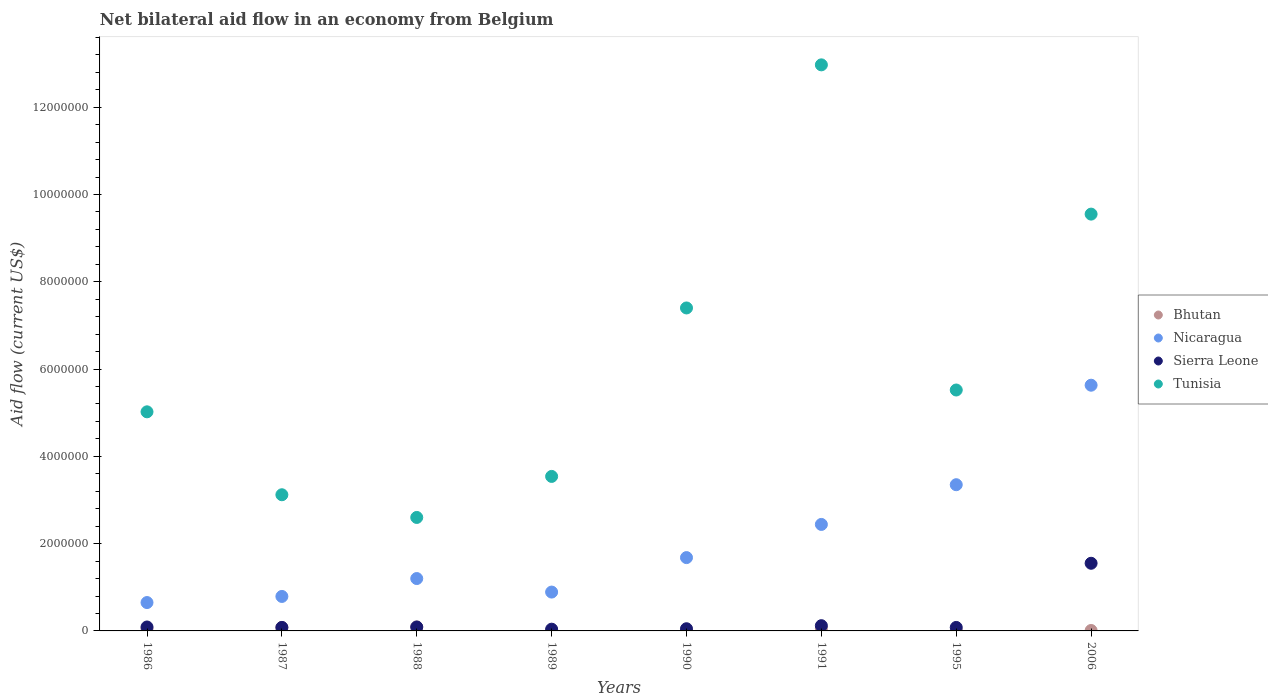How many different coloured dotlines are there?
Offer a terse response. 4. Across all years, what is the maximum net bilateral aid flow in Nicaragua?
Provide a succinct answer. 5.63e+06. Across all years, what is the minimum net bilateral aid flow in Tunisia?
Offer a very short reply. 2.60e+06. In which year was the net bilateral aid flow in Bhutan minimum?
Keep it short and to the point. 1989. What is the total net bilateral aid flow in Bhutan in the graph?
Offer a very short reply. 3.10e+05. What is the difference between the net bilateral aid flow in Bhutan in 1986 and that in 1987?
Provide a succinct answer. -3.00e+04. What is the difference between the net bilateral aid flow in Nicaragua in 1988 and the net bilateral aid flow in Sierra Leone in 1987?
Offer a very short reply. 1.12e+06. What is the average net bilateral aid flow in Bhutan per year?
Provide a short and direct response. 3.88e+04. In the year 1987, what is the difference between the net bilateral aid flow in Sierra Leone and net bilateral aid flow in Tunisia?
Offer a very short reply. -3.04e+06. In how many years, is the net bilateral aid flow in Tunisia greater than 8400000 US$?
Offer a very short reply. 2. What is the difference between the highest and the second highest net bilateral aid flow in Tunisia?
Your answer should be compact. 3.42e+06. What is the difference between the highest and the lowest net bilateral aid flow in Nicaragua?
Your answer should be compact. 4.98e+06. Is it the case that in every year, the sum of the net bilateral aid flow in Nicaragua and net bilateral aid flow in Bhutan  is greater than the sum of net bilateral aid flow in Sierra Leone and net bilateral aid flow in Tunisia?
Give a very brief answer. No. Is it the case that in every year, the sum of the net bilateral aid flow in Nicaragua and net bilateral aid flow in Bhutan  is greater than the net bilateral aid flow in Tunisia?
Make the answer very short. No. Does the net bilateral aid flow in Sierra Leone monotonically increase over the years?
Your answer should be compact. No. Is the net bilateral aid flow in Bhutan strictly less than the net bilateral aid flow in Nicaragua over the years?
Ensure brevity in your answer.  Yes. What is the difference between two consecutive major ticks on the Y-axis?
Offer a very short reply. 2.00e+06. Does the graph contain any zero values?
Your answer should be very brief. No. Does the graph contain grids?
Ensure brevity in your answer.  No. Where does the legend appear in the graph?
Offer a very short reply. Center right. How are the legend labels stacked?
Keep it short and to the point. Vertical. What is the title of the graph?
Your answer should be compact. Net bilateral aid flow in an economy from Belgium. What is the label or title of the X-axis?
Your answer should be very brief. Years. What is the Aid flow (current US$) of Nicaragua in 1986?
Provide a short and direct response. 6.50e+05. What is the Aid flow (current US$) in Tunisia in 1986?
Provide a succinct answer. 5.02e+06. What is the Aid flow (current US$) of Nicaragua in 1987?
Provide a succinct answer. 7.90e+05. What is the Aid flow (current US$) of Sierra Leone in 1987?
Your answer should be compact. 8.00e+04. What is the Aid flow (current US$) of Tunisia in 1987?
Provide a short and direct response. 3.12e+06. What is the Aid flow (current US$) of Nicaragua in 1988?
Keep it short and to the point. 1.20e+06. What is the Aid flow (current US$) of Sierra Leone in 1988?
Your answer should be very brief. 9.00e+04. What is the Aid flow (current US$) in Tunisia in 1988?
Provide a short and direct response. 2.60e+06. What is the Aid flow (current US$) of Bhutan in 1989?
Offer a terse response. 10000. What is the Aid flow (current US$) of Nicaragua in 1989?
Make the answer very short. 8.90e+05. What is the Aid flow (current US$) in Sierra Leone in 1989?
Provide a succinct answer. 4.00e+04. What is the Aid flow (current US$) in Tunisia in 1989?
Your response must be concise. 3.54e+06. What is the Aid flow (current US$) in Nicaragua in 1990?
Your answer should be compact. 1.68e+06. What is the Aid flow (current US$) in Tunisia in 1990?
Ensure brevity in your answer.  7.40e+06. What is the Aid flow (current US$) in Nicaragua in 1991?
Keep it short and to the point. 2.44e+06. What is the Aid flow (current US$) of Sierra Leone in 1991?
Give a very brief answer. 1.20e+05. What is the Aid flow (current US$) in Tunisia in 1991?
Offer a terse response. 1.30e+07. What is the Aid flow (current US$) in Nicaragua in 1995?
Ensure brevity in your answer.  3.35e+06. What is the Aid flow (current US$) in Tunisia in 1995?
Your response must be concise. 5.52e+06. What is the Aid flow (current US$) of Nicaragua in 2006?
Keep it short and to the point. 5.63e+06. What is the Aid flow (current US$) in Sierra Leone in 2006?
Your response must be concise. 1.55e+06. What is the Aid flow (current US$) in Tunisia in 2006?
Offer a terse response. 9.55e+06. Across all years, what is the maximum Aid flow (current US$) of Bhutan?
Offer a terse response. 9.00e+04. Across all years, what is the maximum Aid flow (current US$) in Nicaragua?
Give a very brief answer. 5.63e+06. Across all years, what is the maximum Aid flow (current US$) in Sierra Leone?
Your response must be concise. 1.55e+06. Across all years, what is the maximum Aid flow (current US$) in Tunisia?
Provide a short and direct response. 1.30e+07. Across all years, what is the minimum Aid flow (current US$) in Bhutan?
Offer a terse response. 10000. Across all years, what is the minimum Aid flow (current US$) of Nicaragua?
Your response must be concise. 6.50e+05. Across all years, what is the minimum Aid flow (current US$) in Tunisia?
Your answer should be very brief. 2.60e+06. What is the total Aid flow (current US$) of Nicaragua in the graph?
Your answer should be compact. 1.66e+07. What is the total Aid flow (current US$) in Sierra Leone in the graph?
Provide a short and direct response. 2.10e+06. What is the total Aid flow (current US$) of Tunisia in the graph?
Give a very brief answer. 4.97e+07. What is the difference between the Aid flow (current US$) of Sierra Leone in 1986 and that in 1987?
Your response must be concise. 10000. What is the difference between the Aid flow (current US$) of Tunisia in 1986 and that in 1987?
Your answer should be very brief. 1.90e+06. What is the difference between the Aid flow (current US$) in Nicaragua in 1986 and that in 1988?
Offer a terse response. -5.50e+05. What is the difference between the Aid flow (current US$) in Sierra Leone in 1986 and that in 1988?
Your answer should be very brief. 0. What is the difference between the Aid flow (current US$) of Tunisia in 1986 and that in 1988?
Your answer should be compact. 2.42e+06. What is the difference between the Aid flow (current US$) in Tunisia in 1986 and that in 1989?
Provide a succinct answer. 1.48e+06. What is the difference between the Aid flow (current US$) in Bhutan in 1986 and that in 1990?
Your answer should be compact. 4.00e+04. What is the difference between the Aid flow (current US$) of Nicaragua in 1986 and that in 1990?
Your answer should be very brief. -1.03e+06. What is the difference between the Aid flow (current US$) in Tunisia in 1986 and that in 1990?
Provide a short and direct response. -2.38e+06. What is the difference between the Aid flow (current US$) of Bhutan in 1986 and that in 1991?
Your response must be concise. 0. What is the difference between the Aid flow (current US$) in Nicaragua in 1986 and that in 1991?
Your answer should be very brief. -1.79e+06. What is the difference between the Aid flow (current US$) of Tunisia in 1986 and that in 1991?
Your answer should be very brief. -7.95e+06. What is the difference between the Aid flow (current US$) in Nicaragua in 1986 and that in 1995?
Offer a terse response. -2.70e+06. What is the difference between the Aid flow (current US$) of Tunisia in 1986 and that in 1995?
Ensure brevity in your answer.  -5.00e+05. What is the difference between the Aid flow (current US$) in Nicaragua in 1986 and that in 2006?
Give a very brief answer. -4.98e+06. What is the difference between the Aid flow (current US$) in Sierra Leone in 1986 and that in 2006?
Your answer should be compact. -1.46e+06. What is the difference between the Aid flow (current US$) of Tunisia in 1986 and that in 2006?
Give a very brief answer. -4.53e+06. What is the difference between the Aid flow (current US$) of Bhutan in 1987 and that in 1988?
Your response must be concise. -10000. What is the difference between the Aid flow (current US$) in Nicaragua in 1987 and that in 1988?
Give a very brief answer. -4.10e+05. What is the difference between the Aid flow (current US$) in Tunisia in 1987 and that in 1988?
Provide a short and direct response. 5.20e+05. What is the difference between the Aid flow (current US$) of Bhutan in 1987 and that in 1989?
Your answer should be compact. 7.00e+04. What is the difference between the Aid flow (current US$) of Nicaragua in 1987 and that in 1989?
Your answer should be compact. -1.00e+05. What is the difference between the Aid flow (current US$) of Tunisia in 1987 and that in 1989?
Give a very brief answer. -4.20e+05. What is the difference between the Aid flow (current US$) of Nicaragua in 1987 and that in 1990?
Make the answer very short. -8.90e+05. What is the difference between the Aid flow (current US$) of Sierra Leone in 1987 and that in 1990?
Your answer should be compact. 3.00e+04. What is the difference between the Aid flow (current US$) of Tunisia in 1987 and that in 1990?
Keep it short and to the point. -4.28e+06. What is the difference between the Aid flow (current US$) in Nicaragua in 1987 and that in 1991?
Your answer should be compact. -1.65e+06. What is the difference between the Aid flow (current US$) in Tunisia in 1987 and that in 1991?
Provide a succinct answer. -9.85e+06. What is the difference between the Aid flow (current US$) of Bhutan in 1987 and that in 1995?
Keep it short and to the point. 7.00e+04. What is the difference between the Aid flow (current US$) in Nicaragua in 1987 and that in 1995?
Give a very brief answer. -2.56e+06. What is the difference between the Aid flow (current US$) of Tunisia in 1987 and that in 1995?
Your answer should be compact. -2.40e+06. What is the difference between the Aid flow (current US$) in Bhutan in 1987 and that in 2006?
Provide a short and direct response. 7.00e+04. What is the difference between the Aid flow (current US$) of Nicaragua in 1987 and that in 2006?
Keep it short and to the point. -4.84e+06. What is the difference between the Aid flow (current US$) of Sierra Leone in 1987 and that in 2006?
Make the answer very short. -1.47e+06. What is the difference between the Aid flow (current US$) in Tunisia in 1987 and that in 2006?
Offer a terse response. -6.43e+06. What is the difference between the Aid flow (current US$) in Nicaragua in 1988 and that in 1989?
Keep it short and to the point. 3.10e+05. What is the difference between the Aid flow (current US$) of Sierra Leone in 1988 and that in 1989?
Ensure brevity in your answer.  5.00e+04. What is the difference between the Aid flow (current US$) of Tunisia in 1988 and that in 1989?
Your answer should be very brief. -9.40e+05. What is the difference between the Aid flow (current US$) of Nicaragua in 1988 and that in 1990?
Your response must be concise. -4.80e+05. What is the difference between the Aid flow (current US$) in Tunisia in 1988 and that in 1990?
Ensure brevity in your answer.  -4.80e+06. What is the difference between the Aid flow (current US$) of Bhutan in 1988 and that in 1991?
Offer a terse response. 4.00e+04. What is the difference between the Aid flow (current US$) in Nicaragua in 1988 and that in 1991?
Provide a succinct answer. -1.24e+06. What is the difference between the Aid flow (current US$) in Tunisia in 1988 and that in 1991?
Offer a very short reply. -1.04e+07. What is the difference between the Aid flow (current US$) of Nicaragua in 1988 and that in 1995?
Offer a very short reply. -2.15e+06. What is the difference between the Aid flow (current US$) of Sierra Leone in 1988 and that in 1995?
Offer a terse response. 10000. What is the difference between the Aid flow (current US$) of Tunisia in 1988 and that in 1995?
Offer a very short reply. -2.92e+06. What is the difference between the Aid flow (current US$) of Nicaragua in 1988 and that in 2006?
Provide a succinct answer. -4.43e+06. What is the difference between the Aid flow (current US$) of Sierra Leone in 1988 and that in 2006?
Provide a short and direct response. -1.46e+06. What is the difference between the Aid flow (current US$) in Tunisia in 1988 and that in 2006?
Keep it short and to the point. -6.95e+06. What is the difference between the Aid flow (current US$) in Bhutan in 1989 and that in 1990?
Give a very brief answer. 0. What is the difference between the Aid flow (current US$) of Nicaragua in 1989 and that in 1990?
Keep it short and to the point. -7.90e+05. What is the difference between the Aid flow (current US$) in Tunisia in 1989 and that in 1990?
Offer a terse response. -3.86e+06. What is the difference between the Aid flow (current US$) of Nicaragua in 1989 and that in 1991?
Give a very brief answer. -1.55e+06. What is the difference between the Aid flow (current US$) of Sierra Leone in 1989 and that in 1991?
Your answer should be very brief. -8.00e+04. What is the difference between the Aid flow (current US$) in Tunisia in 1989 and that in 1991?
Offer a very short reply. -9.43e+06. What is the difference between the Aid flow (current US$) in Nicaragua in 1989 and that in 1995?
Keep it short and to the point. -2.46e+06. What is the difference between the Aid flow (current US$) of Tunisia in 1989 and that in 1995?
Your answer should be very brief. -1.98e+06. What is the difference between the Aid flow (current US$) of Nicaragua in 1989 and that in 2006?
Provide a succinct answer. -4.74e+06. What is the difference between the Aid flow (current US$) in Sierra Leone in 1989 and that in 2006?
Keep it short and to the point. -1.51e+06. What is the difference between the Aid flow (current US$) of Tunisia in 1989 and that in 2006?
Offer a very short reply. -6.01e+06. What is the difference between the Aid flow (current US$) of Bhutan in 1990 and that in 1991?
Your response must be concise. -4.00e+04. What is the difference between the Aid flow (current US$) in Nicaragua in 1990 and that in 1991?
Make the answer very short. -7.60e+05. What is the difference between the Aid flow (current US$) in Tunisia in 1990 and that in 1991?
Give a very brief answer. -5.57e+06. What is the difference between the Aid flow (current US$) of Nicaragua in 1990 and that in 1995?
Offer a terse response. -1.67e+06. What is the difference between the Aid flow (current US$) in Tunisia in 1990 and that in 1995?
Ensure brevity in your answer.  1.88e+06. What is the difference between the Aid flow (current US$) of Bhutan in 1990 and that in 2006?
Keep it short and to the point. 0. What is the difference between the Aid flow (current US$) of Nicaragua in 1990 and that in 2006?
Make the answer very short. -3.95e+06. What is the difference between the Aid flow (current US$) in Sierra Leone in 1990 and that in 2006?
Provide a short and direct response. -1.50e+06. What is the difference between the Aid flow (current US$) of Tunisia in 1990 and that in 2006?
Your answer should be very brief. -2.15e+06. What is the difference between the Aid flow (current US$) of Nicaragua in 1991 and that in 1995?
Ensure brevity in your answer.  -9.10e+05. What is the difference between the Aid flow (current US$) in Tunisia in 1991 and that in 1995?
Ensure brevity in your answer.  7.45e+06. What is the difference between the Aid flow (current US$) in Nicaragua in 1991 and that in 2006?
Ensure brevity in your answer.  -3.19e+06. What is the difference between the Aid flow (current US$) of Sierra Leone in 1991 and that in 2006?
Your answer should be very brief. -1.43e+06. What is the difference between the Aid flow (current US$) in Tunisia in 1991 and that in 2006?
Offer a terse response. 3.42e+06. What is the difference between the Aid flow (current US$) of Bhutan in 1995 and that in 2006?
Offer a very short reply. 0. What is the difference between the Aid flow (current US$) of Nicaragua in 1995 and that in 2006?
Provide a short and direct response. -2.28e+06. What is the difference between the Aid flow (current US$) in Sierra Leone in 1995 and that in 2006?
Offer a terse response. -1.47e+06. What is the difference between the Aid flow (current US$) in Tunisia in 1995 and that in 2006?
Provide a short and direct response. -4.03e+06. What is the difference between the Aid flow (current US$) of Bhutan in 1986 and the Aid flow (current US$) of Nicaragua in 1987?
Give a very brief answer. -7.40e+05. What is the difference between the Aid flow (current US$) in Bhutan in 1986 and the Aid flow (current US$) in Sierra Leone in 1987?
Keep it short and to the point. -3.00e+04. What is the difference between the Aid flow (current US$) in Bhutan in 1986 and the Aid flow (current US$) in Tunisia in 1987?
Keep it short and to the point. -3.07e+06. What is the difference between the Aid flow (current US$) in Nicaragua in 1986 and the Aid flow (current US$) in Sierra Leone in 1987?
Provide a short and direct response. 5.70e+05. What is the difference between the Aid flow (current US$) in Nicaragua in 1986 and the Aid flow (current US$) in Tunisia in 1987?
Give a very brief answer. -2.47e+06. What is the difference between the Aid flow (current US$) of Sierra Leone in 1986 and the Aid flow (current US$) of Tunisia in 1987?
Your answer should be very brief. -3.03e+06. What is the difference between the Aid flow (current US$) in Bhutan in 1986 and the Aid flow (current US$) in Nicaragua in 1988?
Provide a succinct answer. -1.15e+06. What is the difference between the Aid flow (current US$) in Bhutan in 1986 and the Aid flow (current US$) in Tunisia in 1988?
Your answer should be compact. -2.55e+06. What is the difference between the Aid flow (current US$) of Nicaragua in 1986 and the Aid flow (current US$) of Sierra Leone in 1988?
Provide a short and direct response. 5.60e+05. What is the difference between the Aid flow (current US$) of Nicaragua in 1986 and the Aid flow (current US$) of Tunisia in 1988?
Give a very brief answer. -1.95e+06. What is the difference between the Aid flow (current US$) in Sierra Leone in 1986 and the Aid flow (current US$) in Tunisia in 1988?
Offer a very short reply. -2.51e+06. What is the difference between the Aid flow (current US$) of Bhutan in 1986 and the Aid flow (current US$) of Nicaragua in 1989?
Offer a very short reply. -8.40e+05. What is the difference between the Aid flow (current US$) in Bhutan in 1986 and the Aid flow (current US$) in Tunisia in 1989?
Offer a very short reply. -3.49e+06. What is the difference between the Aid flow (current US$) of Nicaragua in 1986 and the Aid flow (current US$) of Tunisia in 1989?
Give a very brief answer. -2.89e+06. What is the difference between the Aid flow (current US$) in Sierra Leone in 1986 and the Aid flow (current US$) in Tunisia in 1989?
Keep it short and to the point. -3.45e+06. What is the difference between the Aid flow (current US$) of Bhutan in 1986 and the Aid flow (current US$) of Nicaragua in 1990?
Your response must be concise. -1.63e+06. What is the difference between the Aid flow (current US$) of Bhutan in 1986 and the Aid flow (current US$) of Sierra Leone in 1990?
Offer a very short reply. 0. What is the difference between the Aid flow (current US$) of Bhutan in 1986 and the Aid flow (current US$) of Tunisia in 1990?
Ensure brevity in your answer.  -7.35e+06. What is the difference between the Aid flow (current US$) in Nicaragua in 1986 and the Aid flow (current US$) in Sierra Leone in 1990?
Your answer should be very brief. 6.00e+05. What is the difference between the Aid flow (current US$) in Nicaragua in 1986 and the Aid flow (current US$) in Tunisia in 1990?
Provide a succinct answer. -6.75e+06. What is the difference between the Aid flow (current US$) in Sierra Leone in 1986 and the Aid flow (current US$) in Tunisia in 1990?
Your answer should be very brief. -7.31e+06. What is the difference between the Aid flow (current US$) of Bhutan in 1986 and the Aid flow (current US$) of Nicaragua in 1991?
Provide a succinct answer. -2.39e+06. What is the difference between the Aid flow (current US$) of Bhutan in 1986 and the Aid flow (current US$) of Tunisia in 1991?
Keep it short and to the point. -1.29e+07. What is the difference between the Aid flow (current US$) in Nicaragua in 1986 and the Aid flow (current US$) in Sierra Leone in 1991?
Keep it short and to the point. 5.30e+05. What is the difference between the Aid flow (current US$) of Nicaragua in 1986 and the Aid flow (current US$) of Tunisia in 1991?
Your answer should be compact. -1.23e+07. What is the difference between the Aid flow (current US$) of Sierra Leone in 1986 and the Aid flow (current US$) of Tunisia in 1991?
Your answer should be compact. -1.29e+07. What is the difference between the Aid flow (current US$) of Bhutan in 1986 and the Aid flow (current US$) of Nicaragua in 1995?
Your answer should be compact. -3.30e+06. What is the difference between the Aid flow (current US$) of Bhutan in 1986 and the Aid flow (current US$) of Sierra Leone in 1995?
Offer a very short reply. -3.00e+04. What is the difference between the Aid flow (current US$) in Bhutan in 1986 and the Aid flow (current US$) in Tunisia in 1995?
Give a very brief answer. -5.47e+06. What is the difference between the Aid flow (current US$) in Nicaragua in 1986 and the Aid flow (current US$) in Sierra Leone in 1995?
Offer a terse response. 5.70e+05. What is the difference between the Aid flow (current US$) in Nicaragua in 1986 and the Aid flow (current US$) in Tunisia in 1995?
Ensure brevity in your answer.  -4.87e+06. What is the difference between the Aid flow (current US$) in Sierra Leone in 1986 and the Aid flow (current US$) in Tunisia in 1995?
Your response must be concise. -5.43e+06. What is the difference between the Aid flow (current US$) in Bhutan in 1986 and the Aid flow (current US$) in Nicaragua in 2006?
Your response must be concise. -5.58e+06. What is the difference between the Aid flow (current US$) of Bhutan in 1986 and the Aid flow (current US$) of Sierra Leone in 2006?
Ensure brevity in your answer.  -1.50e+06. What is the difference between the Aid flow (current US$) in Bhutan in 1986 and the Aid flow (current US$) in Tunisia in 2006?
Provide a short and direct response. -9.50e+06. What is the difference between the Aid flow (current US$) in Nicaragua in 1986 and the Aid flow (current US$) in Sierra Leone in 2006?
Make the answer very short. -9.00e+05. What is the difference between the Aid flow (current US$) in Nicaragua in 1986 and the Aid flow (current US$) in Tunisia in 2006?
Provide a succinct answer. -8.90e+06. What is the difference between the Aid flow (current US$) in Sierra Leone in 1986 and the Aid flow (current US$) in Tunisia in 2006?
Offer a terse response. -9.46e+06. What is the difference between the Aid flow (current US$) of Bhutan in 1987 and the Aid flow (current US$) of Nicaragua in 1988?
Offer a very short reply. -1.12e+06. What is the difference between the Aid flow (current US$) in Bhutan in 1987 and the Aid flow (current US$) in Tunisia in 1988?
Your answer should be compact. -2.52e+06. What is the difference between the Aid flow (current US$) in Nicaragua in 1987 and the Aid flow (current US$) in Sierra Leone in 1988?
Provide a short and direct response. 7.00e+05. What is the difference between the Aid flow (current US$) in Nicaragua in 1987 and the Aid flow (current US$) in Tunisia in 1988?
Provide a short and direct response. -1.81e+06. What is the difference between the Aid flow (current US$) in Sierra Leone in 1987 and the Aid flow (current US$) in Tunisia in 1988?
Give a very brief answer. -2.52e+06. What is the difference between the Aid flow (current US$) in Bhutan in 1987 and the Aid flow (current US$) in Nicaragua in 1989?
Make the answer very short. -8.10e+05. What is the difference between the Aid flow (current US$) of Bhutan in 1987 and the Aid flow (current US$) of Tunisia in 1989?
Provide a short and direct response. -3.46e+06. What is the difference between the Aid flow (current US$) of Nicaragua in 1987 and the Aid flow (current US$) of Sierra Leone in 1989?
Your answer should be compact. 7.50e+05. What is the difference between the Aid flow (current US$) of Nicaragua in 1987 and the Aid flow (current US$) of Tunisia in 1989?
Give a very brief answer. -2.75e+06. What is the difference between the Aid flow (current US$) of Sierra Leone in 1987 and the Aid flow (current US$) of Tunisia in 1989?
Your answer should be compact. -3.46e+06. What is the difference between the Aid flow (current US$) of Bhutan in 1987 and the Aid flow (current US$) of Nicaragua in 1990?
Make the answer very short. -1.60e+06. What is the difference between the Aid flow (current US$) of Bhutan in 1987 and the Aid flow (current US$) of Sierra Leone in 1990?
Your answer should be very brief. 3.00e+04. What is the difference between the Aid flow (current US$) in Bhutan in 1987 and the Aid flow (current US$) in Tunisia in 1990?
Provide a short and direct response. -7.32e+06. What is the difference between the Aid flow (current US$) of Nicaragua in 1987 and the Aid flow (current US$) of Sierra Leone in 1990?
Provide a succinct answer. 7.40e+05. What is the difference between the Aid flow (current US$) of Nicaragua in 1987 and the Aid flow (current US$) of Tunisia in 1990?
Your response must be concise. -6.61e+06. What is the difference between the Aid flow (current US$) of Sierra Leone in 1987 and the Aid flow (current US$) of Tunisia in 1990?
Provide a short and direct response. -7.32e+06. What is the difference between the Aid flow (current US$) in Bhutan in 1987 and the Aid flow (current US$) in Nicaragua in 1991?
Your answer should be very brief. -2.36e+06. What is the difference between the Aid flow (current US$) in Bhutan in 1987 and the Aid flow (current US$) in Sierra Leone in 1991?
Your answer should be very brief. -4.00e+04. What is the difference between the Aid flow (current US$) in Bhutan in 1987 and the Aid flow (current US$) in Tunisia in 1991?
Your answer should be very brief. -1.29e+07. What is the difference between the Aid flow (current US$) in Nicaragua in 1987 and the Aid flow (current US$) in Sierra Leone in 1991?
Offer a very short reply. 6.70e+05. What is the difference between the Aid flow (current US$) of Nicaragua in 1987 and the Aid flow (current US$) of Tunisia in 1991?
Provide a short and direct response. -1.22e+07. What is the difference between the Aid flow (current US$) of Sierra Leone in 1987 and the Aid flow (current US$) of Tunisia in 1991?
Ensure brevity in your answer.  -1.29e+07. What is the difference between the Aid flow (current US$) in Bhutan in 1987 and the Aid flow (current US$) in Nicaragua in 1995?
Keep it short and to the point. -3.27e+06. What is the difference between the Aid flow (current US$) in Bhutan in 1987 and the Aid flow (current US$) in Sierra Leone in 1995?
Offer a terse response. 0. What is the difference between the Aid flow (current US$) of Bhutan in 1987 and the Aid flow (current US$) of Tunisia in 1995?
Ensure brevity in your answer.  -5.44e+06. What is the difference between the Aid flow (current US$) of Nicaragua in 1987 and the Aid flow (current US$) of Sierra Leone in 1995?
Your answer should be compact. 7.10e+05. What is the difference between the Aid flow (current US$) of Nicaragua in 1987 and the Aid flow (current US$) of Tunisia in 1995?
Provide a succinct answer. -4.73e+06. What is the difference between the Aid flow (current US$) in Sierra Leone in 1987 and the Aid flow (current US$) in Tunisia in 1995?
Provide a short and direct response. -5.44e+06. What is the difference between the Aid flow (current US$) in Bhutan in 1987 and the Aid flow (current US$) in Nicaragua in 2006?
Ensure brevity in your answer.  -5.55e+06. What is the difference between the Aid flow (current US$) in Bhutan in 1987 and the Aid flow (current US$) in Sierra Leone in 2006?
Provide a short and direct response. -1.47e+06. What is the difference between the Aid flow (current US$) of Bhutan in 1987 and the Aid flow (current US$) of Tunisia in 2006?
Your answer should be very brief. -9.47e+06. What is the difference between the Aid flow (current US$) of Nicaragua in 1987 and the Aid flow (current US$) of Sierra Leone in 2006?
Your answer should be compact. -7.60e+05. What is the difference between the Aid flow (current US$) of Nicaragua in 1987 and the Aid flow (current US$) of Tunisia in 2006?
Your answer should be compact. -8.76e+06. What is the difference between the Aid flow (current US$) of Sierra Leone in 1987 and the Aid flow (current US$) of Tunisia in 2006?
Provide a succinct answer. -9.47e+06. What is the difference between the Aid flow (current US$) in Bhutan in 1988 and the Aid flow (current US$) in Nicaragua in 1989?
Your answer should be compact. -8.00e+05. What is the difference between the Aid flow (current US$) of Bhutan in 1988 and the Aid flow (current US$) of Sierra Leone in 1989?
Your response must be concise. 5.00e+04. What is the difference between the Aid flow (current US$) of Bhutan in 1988 and the Aid flow (current US$) of Tunisia in 1989?
Your answer should be compact. -3.45e+06. What is the difference between the Aid flow (current US$) of Nicaragua in 1988 and the Aid flow (current US$) of Sierra Leone in 1989?
Your answer should be very brief. 1.16e+06. What is the difference between the Aid flow (current US$) of Nicaragua in 1988 and the Aid flow (current US$) of Tunisia in 1989?
Give a very brief answer. -2.34e+06. What is the difference between the Aid flow (current US$) of Sierra Leone in 1988 and the Aid flow (current US$) of Tunisia in 1989?
Provide a succinct answer. -3.45e+06. What is the difference between the Aid flow (current US$) of Bhutan in 1988 and the Aid flow (current US$) of Nicaragua in 1990?
Provide a short and direct response. -1.59e+06. What is the difference between the Aid flow (current US$) of Bhutan in 1988 and the Aid flow (current US$) of Tunisia in 1990?
Ensure brevity in your answer.  -7.31e+06. What is the difference between the Aid flow (current US$) of Nicaragua in 1988 and the Aid flow (current US$) of Sierra Leone in 1990?
Offer a terse response. 1.15e+06. What is the difference between the Aid flow (current US$) in Nicaragua in 1988 and the Aid flow (current US$) in Tunisia in 1990?
Your answer should be compact. -6.20e+06. What is the difference between the Aid flow (current US$) in Sierra Leone in 1988 and the Aid flow (current US$) in Tunisia in 1990?
Keep it short and to the point. -7.31e+06. What is the difference between the Aid flow (current US$) of Bhutan in 1988 and the Aid flow (current US$) of Nicaragua in 1991?
Keep it short and to the point. -2.35e+06. What is the difference between the Aid flow (current US$) of Bhutan in 1988 and the Aid flow (current US$) of Sierra Leone in 1991?
Provide a short and direct response. -3.00e+04. What is the difference between the Aid flow (current US$) in Bhutan in 1988 and the Aid flow (current US$) in Tunisia in 1991?
Provide a succinct answer. -1.29e+07. What is the difference between the Aid flow (current US$) of Nicaragua in 1988 and the Aid flow (current US$) of Sierra Leone in 1991?
Ensure brevity in your answer.  1.08e+06. What is the difference between the Aid flow (current US$) of Nicaragua in 1988 and the Aid flow (current US$) of Tunisia in 1991?
Provide a short and direct response. -1.18e+07. What is the difference between the Aid flow (current US$) in Sierra Leone in 1988 and the Aid flow (current US$) in Tunisia in 1991?
Offer a very short reply. -1.29e+07. What is the difference between the Aid flow (current US$) of Bhutan in 1988 and the Aid flow (current US$) of Nicaragua in 1995?
Keep it short and to the point. -3.26e+06. What is the difference between the Aid flow (current US$) in Bhutan in 1988 and the Aid flow (current US$) in Sierra Leone in 1995?
Give a very brief answer. 10000. What is the difference between the Aid flow (current US$) in Bhutan in 1988 and the Aid flow (current US$) in Tunisia in 1995?
Your response must be concise. -5.43e+06. What is the difference between the Aid flow (current US$) of Nicaragua in 1988 and the Aid flow (current US$) of Sierra Leone in 1995?
Keep it short and to the point. 1.12e+06. What is the difference between the Aid flow (current US$) in Nicaragua in 1988 and the Aid flow (current US$) in Tunisia in 1995?
Provide a short and direct response. -4.32e+06. What is the difference between the Aid flow (current US$) of Sierra Leone in 1988 and the Aid flow (current US$) of Tunisia in 1995?
Keep it short and to the point. -5.43e+06. What is the difference between the Aid flow (current US$) of Bhutan in 1988 and the Aid flow (current US$) of Nicaragua in 2006?
Make the answer very short. -5.54e+06. What is the difference between the Aid flow (current US$) of Bhutan in 1988 and the Aid flow (current US$) of Sierra Leone in 2006?
Your answer should be compact. -1.46e+06. What is the difference between the Aid flow (current US$) in Bhutan in 1988 and the Aid flow (current US$) in Tunisia in 2006?
Provide a succinct answer. -9.46e+06. What is the difference between the Aid flow (current US$) in Nicaragua in 1988 and the Aid flow (current US$) in Sierra Leone in 2006?
Offer a terse response. -3.50e+05. What is the difference between the Aid flow (current US$) of Nicaragua in 1988 and the Aid flow (current US$) of Tunisia in 2006?
Your answer should be very brief. -8.35e+06. What is the difference between the Aid flow (current US$) in Sierra Leone in 1988 and the Aid flow (current US$) in Tunisia in 2006?
Provide a short and direct response. -9.46e+06. What is the difference between the Aid flow (current US$) in Bhutan in 1989 and the Aid flow (current US$) in Nicaragua in 1990?
Keep it short and to the point. -1.67e+06. What is the difference between the Aid flow (current US$) of Bhutan in 1989 and the Aid flow (current US$) of Sierra Leone in 1990?
Make the answer very short. -4.00e+04. What is the difference between the Aid flow (current US$) in Bhutan in 1989 and the Aid flow (current US$) in Tunisia in 1990?
Offer a very short reply. -7.39e+06. What is the difference between the Aid flow (current US$) in Nicaragua in 1989 and the Aid flow (current US$) in Sierra Leone in 1990?
Offer a terse response. 8.40e+05. What is the difference between the Aid flow (current US$) of Nicaragua in 1989 and the Aid flow (current US$) of Tunisia in 1990?
Offer a terse response. -6.51e+06. What is the difference between the Aid flow (current US$) of Sierra Leone in 1989 and the Aid flow (current US$) of Tunisia in 1990?
Give a very brief answer. -7.36e+06. What is the difference between the Aid flow (current US$) in Bhutan in 1989 and the Aid flow (current US$) in Nicaragua in 1991?
Your answer should be very brief. -2.43e+06. What is the difference between the Aid flow (current US$) in Bhutan in 1989 and the Aid flow (current US$) in Sierra Leone in 1991?
Give a very brief answer. -1.10e+05. What is the difference between the Aid flow (current US$) in Bhutan in 1989 and the Aid flow (current US$) in Tunisia in 1991?
Keep it short and to the point. -1.30e+07. What is the difference between the Aid flow (current US$) of Nicaragua in 1989 and the Aid flow (current US$) of Sierra Leone in 1991?
Make the answer very short. 7.70e+05. What is the difference between the Aid flow (current US$) of Nicaragua in 1989 and the Aid flow (current US$) of Tunisia in 1991?
Offer a terse response. -1.21e+07. What is the difference between the Aid flow (current US$) of Sierra Leone in 1989 and the Aid flow (current US$) of Tunisia in 1991?
Offer a terse response. -1.29e+07. What is the difference between the Aid flow (current US$) in Bhutan in 1989 and the Aid flow (current US$) in Nicaragua in 1995?
Offer a very short reply. -3.34e+06. What is the difference between the Aid flow (current US$) of Bhutan in 1989 and the Aid flow (current US$) of Tunisia in 1995?
Your answer should be compact. -5.51e+06. What is the difference between the Aid flow (current US$) of Nicaragua in 1989 and the Aid flow (current US$) of Sierra Leone in 1995?
Offer a very short reply. 8.10e+05. What is the difference between the Aid flow (current US$) in Nicaragua in 1989 and the Aid flow (current US$) in Tunisia in 1995?
Your answer should be compact. -4.63e+06. What is the difference between the Aid flow (current US$) of Sierra Leone in 1989 and the Aid flow (current US$) of Tunisia in 1995?
Provide a succinct answer. -5.48e+06. What is the difference between the Aid flow (current US$) in Bhutan in 1989 and the Aid flow (current US$) in Nicaragua in 2006?
Provide a short and direct response. -5.62e+06. What is the difference between the Aid flow (current US$) in Bhutan in 1989 and the Aid flow (current US$) in Sierra Leone in 2006?
Offer a terse response. -1.54e+06. What is the difference between the Aid flow (current US$) of Bhutan in 1989 and the Aid flow (current US$) of Tunisia in 2006?
Your answer should be very brief. -9.54e+06. What is the difference between the Aid flow (current US$) in Nicaragua in 1989 and the Aid flow (current US$) in Sierra Leone in 2006?
Your answer should be compact. -6.60e+05. What is the difference between the Aid flow (current US$) in Nicaragua in 1989 and the Aid flow (current US$) in Tunisia in 2006?
Make the answer very short. -8.66e+06. What is the difference between the Aid flow (current US$) of Sierra Leone in 1989 and the Aid flow (current US$) of Tunisia in 2006?
Keep it short and to the point. -9.51e+06. What is the difference between the Aid flow (current US$) in Bhutan in 1990 and the Aid flow (current US$) in Nicaragua in 1991?
Your answer should be very brief. -2.43e+06. What is the difference between the Aid flow (current US$) in Bhutan in 1990 and the Aid flow (current US$) in Sierra Leone in 1991?
Ensure brevity in your answer.  -1.10e+05. What is the difference between the Aid flow (current US$) in Bhutan in 1990 and the Aid flow (current US$) in Tunisia in 1991?
Ensure brevity in your answer.  -1.30e+07. What is the difference between the Aid flow (current US$) in Nicaragua in 1990 and the Aid flow (current US$) in Sierra Leone in 1991?
Your answer should be compact. 1.56e+06. What is the difference between the Aid flow (current US$) in Nicaragua in 1990 and the Aid flow (current US$) in Tunisia in 1991?
Offer a very short reply. -1.13e+07. What is the difference between the Aid flow (current US$) of Sierra Leone in 1990 and the Aid flow (current US$) of Tunisia in 1991?
Give a very brief answer. -1.29e+07. What is the difference between the Aid flow (current US$) of Bhutan in 1990 and the Aid flow (current US$) of Nicaragua in 1995?
Your answer should be very brief. -3.34e+06. What is the difference between the Aid flow (current US$) of Bhutan in 1990 and the Aid flow (current US$) of Sierra Leone in 1995?
Make the answer very short. -7.00e+04. What is the difference between the Aid flow (current US$) in Bhutan in 1990 and the Aid flow (current US$) in Tunisia in 1995?
Make the answer very short. -5.51e+06. What is the difference between the Aid flow (current US$) in Nicaragua in 1990 and the Aid flow (current US$) in Sierra Leone in 1995?
Make the answer very short. 1.60e+06. What is the difference between the Aid flow (current US$) in Nicaragua in 1990 and the Aid flow (current US$) in Tunisia in 1995?
Offer a terse response. -3.84e+06. What is the difference between the Aid flow (current US$) of Sierra Leone in 1990 and the Aid flow (current US$) of Tunisia in 1995?
Offer a terse response. -5.47e+06. What is the difference between the Aid flow (current US$) of Bhutan in 1990 and the Aid flow (current US$) of Nicaragua in 2006?
Your answer should be very brief. -5.62e+06. What is the difference between the Aid flow (current US$) of Bhutan in 1990 and the Aid flow (current US$) of Sierra Leone in 2006?
Give a very brief answer. -1.54e+06. What is the difference between the Aid flow (current US$) of Bhutan in 1990 and the Aid flow (current US$) of Tunisia in 2006?
Make the answer very short. -9.54e+06. What is the difference between the Aid flow (current US$) in Nicaragua in 1990 and the Aid flow (current US$) in Tunisia in 2006?
Provide a short and direct response. -7.87e+06. What is the difference between the Aid flow (current US$) of Sierra Leone in 1990 and the Aid flow (current US$) of Tunisia in 2006?
Keep it short and to the point. -9.50e+06. What is the difference between the Aid flow (current US$) of Bhutan in 1991 and the Aid flow (current US$) of Nicaragua in 1995?
Offer a terse response. -3.30e+06. What is the difference between the Aid flow (current US$) in Bhutan in 1991 and the Aid flow (current US$) in Sierra Leone in 1995?
Provide a short and direct response. -3.00e+04. What is the difference between the Aid flow (current US$) of Bhutan in 1991 and the Aid flow (current US$) of Tunisia in 1995?
Keep it short and to the point. -5.47e+06. What is the difference between the Aid flow (current US$) in Nicaragua in 1991 and the Aid flow (current US$) in Sierra Leone in 1995?
Make the answer very short. 2.36e+06. What is the difference between the Aid flow (current US$) of Nicaragua in 1991 and the Aid flow (current US$) of Tunisia in 1995?
Ensure brevity in your answer.  -3.08e+06. What is the difference between the Aid flow (current US$) of Sierra Leone in 1991 and the Aid flow (current US$) of Tunisia in 1995?
Offer a very short reply. -5.40e+06. What is the difference between the Aid flow (current US$) of Bhutan in 1991 and the Aid flow (current US$) of Nicaragua in 2006?
Your response must be concise. -5.58e+06. What is the difference between the Aid flow (current US$) in Bhutan in 1991 and the Aid flow (current US$) in Sierra Leone in 2006?
Ensure brevity in your answer.  -1.50e+06. What is the difference between the Aid flow (current US$) in Bhutan in 1991 and the Aid flow (current US$) in Tunisia in 2006?
Offer a very short reply. -9.50e+06. What is the difference between the Aid flow (current US$) in Nicaragua in 1991 and the Aid flow (current US$) in Sierra Leone in 2006?
Your response must be concise. 8.90e+05. What is the difference between the Aid flow (current US$) of Nicaragua in 1991 and the Aid flow (current US$) of Tunisia in 2006?
Keep it short and to the point. -7.11e+06. What is the difference between the Aid flow (current US$) in Sierra Leone in 1991 and the Aid flow (current US$) in Tunisia in 2006?
Provide a short and direct response. -9.43e+06. What is the difference between the Aid flow (current US$) in Bhutan in 1995 and the Aid flow (current US$) in Nicaragua in 2006?
Provide a short and direct response. -5.62e+06. What is the difference between the Aid flow (current US$) in Bhutan in 1995 and the Aid flow (current US$) in Sierra Leone in 2006?
Give a very brief answer. -1.54e+06. What is the difference between the Aid flow (current US$) of Bhutan in 1995 and the Aid flow (current US$) of Tunisia in 2006?
Provide a succinct answer. -9.54e+06. What is the difference between the Aid flow (current US$) of Nicaragua in 1995 and the Aid flow (current US$) of Sierra Leone in 2006?
Give a very brief answer. 1.80e+06. What is the difference between the Aid flow (current US$) in Nicaragua in 1995 and the Aid flow (current US$) in Tunisia in 2006?
Provide a short and direct response. -6.20e+06. What is the difference between the Aid flow (current US$) of Sierra Leone in 1995 and the Aid flow (current US$) of Tunisia in 2006?
Make the answer very short. -9.47e+06. What is the average Aid flow (current US$) of Bhutan per year?
Offer a terse response. 3.88e+04. What is the average Aid flow (current US$) in Nicaragua per year?
Offer a terse response. 2.08e+06. What is the average Aid flow (current US$) in Sierra Leone per year?
Your answer should be compact. 2.62e+05. What is the average Aid flow (current US$) of Tunisia per year?
Ensure brevity in your answer.  6.22e+06. In the year 1986, what is the difference between the Aid flow (current US$) of Bhutan and Aid flow (current US$) of Nicaragua?
Your answer should be compact. -6.00e+05. In the year 1986, what is the difference between the Aid flow (current US$) in Bhutan and Aid flow (current US$) in Tunisia?
Your response must be concise. -4.97e+06. In the year 1986, what is the difference between the Aid flow (current US$) of Nicaragua and Aid flow (current US$) of Sierra Leone?
Your answer should be compact. 5.60e+05. In the year 1986, what is the difference between the Aid flow (current US$) of Nicaragua and Aid flow (current US$) of Tunisia?
Offer a very short reply. -4.37e+06. In the year 1986, what is the difference between the Aid flow (current US$) in Sierra Leone and Aid flow (current US$) in Tunisia?
Give a very brief answer. -4.93e+06. In the year 1987, what is the difference between the Aid flow (current US$) in Bhutan and Aid flow (current US$) in Nicaragua?
Your answer should be compact. -7.10e+05. In the year 1987, what is the difference between the Aid flow (current US$) of Bhutan and Aid flow (current US$) of Sierra Leone?
Provide a succinct answer. 0. In the year 1987, what is the difference between the Aid flow (current US$) of Bhutan and Aid flow (current US$) of Tunisia?
Your response must be concise. -3.04e+06. In the year 1987, what is the difference between the Aid flow (current US$) of Nicaragua and Aid flow (current US$) of Sierra Leone?
Your response must be concise. 7.10e+05. In the year 1987, what is the difference between the Aid flow (current US$) in Nicaragua and Aid flow (current US$) in Tunisia?
Give a very brief answer. -2.33e+06. In the year 1987, what is the difference between the Aid flow (current US$) in Sierra Leone and Aid flow (current US$) in Tunisia?
Provide a succinct answer. -3.04e+06. In the year 1988, what is the difference between the Aid flow (current US$) in Bhutan and Aid flow (current US$) in Nicaragua?
Keep it short and to the point. -1.11e+06. In the year 1988, what is the difference between the Aid flow (current US$) of Bhutan and Aid flow (current US$) of Sierra Leone?
Give a very brief answer. 0. In the year 1988, what is the difference between the Aid flow (current US$) in Bhutan and Aid flow (current US$) in Tunisia?
Provide a short and direct response. -2.51e+06. In the year 1988, what is the difference between the Aid flow (current US$) of Nicaragua and Aid flow (current US$) of Sierra Leone?
Provide a succinct answer. 1.11e+06. In the year 1988, what is the difference between the Aid flow (current US$) in Nicaragua and Aid flow (current US$) in Tunisia?
Ensure brevity in your answer.  -1.40e+06. In the year 1988, what is the difference between the Aid flow (current US$) of Sierra Leone and Aid flow (current US$) of Tunisia?
Keep it short and to the point. -2.51e+06. In the year 1989, what is the difference between the Aid flow (current US$) of Bhutan and Aid flow (current US$) of Nicaragua?
Make the answer very short. -8.80e+05. In the year 1989, what is the difference between the Aid flow (current US$) in Bhutan and Aid flow (current US$) in Sierra Leone?
Provide a short and direct response. -3.00e+04. In the year 1989, what is the difference between the Aid flow (current US$) in Bhutan and Aid flow (current US$) in Tunisia?
Provide a short and direct response. -3.53e+06. In the year 1989, what is the difference between the Aid flow (current US$) in Nicaragua and Aid flow (current US$) in Sierra Leone?
Give a very brief answer. 8.50e+05. In the year 1989, what is the difference between the Aid flow (current US$) in Nicaragua and Aid flow (current US$) in Tunisia?
Your response must be concise. -2.65e+06. In the year 1989, what is the difference between the Aid flow (current US$) in Sierra Leone and Aid flow (current US$) in Tunisia?
Give a very brief answer. -3.50e+06. In the year 1990, what is the difference between the Aid flow (current US$) in Bhutan and Aid flow (current US$) in Nicaragua?
Your answer should be compact. -1.67e+06. In the year 1990, what is the difference between the Aid flow (current US$) of Bhutan and Aid flow (current US$) of Tunisia?
Keep it short and to the point. -7.39e+06. In the year 1990, what is the difference between the Aid flow (current US$) in Nicaragua and Aid flow (current US$) in Sierra Leone?
Keep it short and to the point. 1.63e+06. In the year 1990, what is the difference between the Aid flow (current US$) in Nicaragua and Aid flow (current US$) in Tunisia?
Ensure brevity in your answer.  -5.72e+06. In the year 1990, what is the difference between the Aid flow (current US$) in Sierra Leone and Aid flow (current US$) in Tunisia?
Your answer should be compact. -7.35e+06. In the year 1991, what is the difference between the Aid flow (current US$) in Bhutan and Aid flow (current US$) in Nicaragua?
Provide a succinct answer. -2.39e+06. In the year 1991, what is the difference between the Aid flow (current US$) of Bhutan and Aid flow (current US$) of Tunisia?
Your answer should be compact. -1.29e+07. In the year 1991, what is the difference between the Aid flow (current US$) in Nicaragua and Aid flow (current US$) in Sierra Leone?
Make the answer very short. 2.32e+06. In the year 1991, what is the difference between the Aid flow (current US$) in Nicaragua and Aid flow (current US$) in Tunisia?
Provide a succinct answer. -1.05e+07. In the year 1991, what is the difference between the Aid flow (current US$) in Sierra Leone and Aid flow (current US$) in Tunisia?
Your response must be concise. -1.28e+07. In the year 1995, what is the difference between the Aid flow (current US$) of Bhutan and Aid flow (current US$) of Nicaragua?
Offer a very short reply. -3.34e+06. In the year 1995, what is the difference between the Aid flow (current US$) of Bhutan and Aid flow (current US$) of Tunisia?
Ensure brevity in your answer.  -5.51e+06. In the year 1995, what is the difference between the Aid flow (current US$) of Nicaragua and Aid flow (current US$) of Sierra Leone?
Your answer should be compact. 3.27e+06. In the year 1995, what is the difference between the Aid flow (current US$) of Nicaragua and Aid flow (current US$) of Tunisia?
Give a very brief answer. -2.17e+06. In the year 1995, what is the difference between the Aid flow (current US$) in Sierra Leone and Aid flow (current US$) in Tunisia?
Your answer should be compact. -5.44e+06. In the year 2006, what is the difference between the Aid flow (current US$) in Bhutan and Aid flow (current US$) in Nicaragua?
Your answer should be compact. -5.62e+06. In the year 2006, what is the difference between the Aid flow (current US$) of Bhutan and Aid flow (current US$) of Sierra Leone?
Provide a succinct answer. -1.54e+06. In the year 2006, what is the difference between the Aid flow (current US$) in Bhutan and Aid flow (current US$) in Tunisia?
Your answer should be very brief. -9.54e+06. In the year 2006, what is the difference between the Aid flow (current US$) of Nicaragua and Aid flow (current US$) of Sierra Leone?
Make the answer very short. 4.08e+06. In the year 2006, what is the difference between the Aid flow (current US$) in Nicaragua and Aid flow (current US$) in Tunisia?
Your answer should be very brief. -3.92e+06. In the year 2006, what is the difference between the Aid flow (current US$) in Sierra Leone and Aid flow (current US$) in Tunisia?
Ensure brevity in your answer.  -8.00e+06. What is the ratio of the Aid flow (current US$) in Bhutan in 1986 to that in 1987?
Your answer should be very brief. 0.62. What is the ratio of the Aid flow (current US$) in Nicaragua in 1986 to that in 1987?
Your answer should be compact. 0.82. What is the ratio of the Aid flow (current US$) in Sierra Leone in 1986 to that in 1987?
Make the answer very short. 1.12. What is the ratio of the Aid flow (current US$) in Tunisia in 1986 to that in 1987?
Offer a terse response. 1.61. What is the ratio of the Aid flow (current US$) in Bhutan in 1986 to that in 1988?
Your response must be concise. 0.56. What is the ratio of the Aid flow (current US$) of Nicaragua in 1986 to that in 1988?
Ensure brevity in your answer.  0.54. What is the ratio of the Aid flow (current US$) in Sierra Leone in 1986 to that in 1988?
Offer a terse response. 1. What is the ratio of the Aid flow (current US$) in Tunisia in 1986 to that in 1988?
Your answer should be very brief. 1.93. What is the ratio of the Aid flow (current US$) in Nicaragua in 1986 to that in 1989?
Provide a succinct answer. 0.73. What is the ratio of the Aid flow (current US$) of Sierra Leone in 1986 to that in 1989?
Give a very brief answer. 2.25. What is the ratio of the Aid flow (current US$) of Tunisia in 1986 to that in 1989?
Offer a very short reply. 1.42. What is the ratio of the Aid flow (current US$) of Nicaragua in 1986 to that in 1990?
Keep it short and to the point. 0.39. What is the ratio of the Aid flow (current US$) in Sierra Leone in 1986 to that in 1990?
Provide a succinct answer. 1.8. What is the ratio of the Aid flow (current US$) in Tunisia in 1986 to that in 1990?
Offer a terse response. 0.68. What is the ratio of the Aid flow (current US$) in Bhutan in 1986 to that in 1991?
Your answer should be compact. 1. What is the ratio of the Aid flow (current US$) of Nicaragua in 1986 to that in 1991?
Offer a terse response. 0.27. What is the ratio of the Aid flow (current US$) in Sierra Leone in 1986 to that in 1991?
Give a very brief answer. 0.75. What is the ratio of the Aid flow (current US$) of Tunisia in 1986 to that in 1991?
Your answer should be compact. 0.39. What is the ratio of the Aid flow (current US$) of Nicaragua in 1986 to that in 1995?
Your answer should be very brief. 0.19. What is the ratio of the Aid flow (current US$) of Tunisia in 1986 to that in 1995?
Provide a succinct answer. 0.91. What is the ratio of the Aid flow (current US$) in Nicaragua in 1986 to that in 2006?
Provide a succinct answer. 0.12. What is the ratio of the Aid flow (current US$) in Sierra Leone in 1986 to that in 2006?
Offer a terse response. 0.06. What is the ratio of the Aid flow (current US$) of Tunisia in 1986 to that in 2006?
Provide a short and direct response. 0.53. What is the ratio of the Aid flow (current US$) in Nicaragua in 1987 to that in 1988?
Give a very brief answer. 0.66. What is the ratio of the Aid flow (current US$) of Sierra Leone in 1987 to that in 1988?
Offer a terse response. 0.89. What is the ratio of the Aid flow (current US$) of Tunisia in 1987 to that in 1988?
Offer a terse response. 1.2. What is the ratio of the Aid flow (current US$) of Nicaragua in 1987 to that in 1989?
Give a very brief answer. 0.89. What is the ratio of the Aid flow (current US$) of Sierra Leone in 1987 to that in 1989?
Ensure brevity in your answer.  2. What is the ratio of the Aid flow (current US$) of Tunisia in 1987 to that in 1989?
Provide a short and direct response. 0.88. What is the ratio of the Aid flow (current US$) in Nicaragua in 1987 to that in 1990?
Offer a very short reply. 0.47. What is the ratio of the Aid flow (current US$) in Sierra Leone in 1987 to that in 1990?
Your answer should be very brief. 1.6. What is the ratio of the Aid flow (current US$) in Tunisia in 1987 to that in 1990?
Your answer should be compact. 0.42. What is the ratio of the Aid flow (current US$) of Bhutan in 1987 to that in 1991?
Provide a succinct answer. 1.6. What is the ratio of the Aid flow (current US$) in Nicaragua in 1987 to that in 1991?
Keep it short and to the point. 0.32. What is the ratio of the Aid flow (current US$) in Tunisia in 1987 to that in 1991?
Keep it short and to the point. 0.24. What is the ratio of the Aid flow (current US$) in Nicaragua in 1987 to that in 1995?
Ensure brevity in your answer.  0.24. What is the ratio of the Aid flow (current US$) of Tunisia in 1987 to that in 1995?
Your response must be concise. 0.57. What is the ratio of the Aid flow (current US$) in Bhutan in 1987 to that in 2006?
Make the answer very short. 8. What is the ratio of the Aid flow (current US$) in Nicaragua in 1987 to that in 2006?
Your answer should be compact. 0.14. What is the ratio of the Aid flow (current US$) of Sierra Leone in 1987 to that in 2006?
Ensure brevity in your answer.  0.05. What is the ratio of the Aid flow (current US$) in Tunisia in 1987 to that in 2006?
Make the answer very short. 0.33. What is the ratio of the Aid flow (current US$) in Bhutan in 1988 to that in 1989?
Offer a terse response. 9. What is the ratio of the Aid flow (current US$) in Nicaragua in 1988 to that in 1989?
Offer a terse response. 1.35. What is the ratio of the Aid flow (current US$) in Sierra Leone in 1988 to that in 1989?
Offer a terse response. 2.25. What is the ratio of the Aid flow (current US$) in Tunisia in 1988 to that in 1989?
Your answer should be compact. 0.73. What is the ratio of the Aid flow (current US$) in Bhutan in 1988 to that in 1990?
Make the answer very short. 9. What is the ratio of the Aid flow (current US$) in Tunisia in 1988 to that in 1990?
Your response must be concise. 0.35. What is the ratio of the Aid flow (current US$) of Bhutan in 1988 to that in 1991?
Provide a succinct answer. 1.8. What is the ratio of the Aid flow (current US$) of Nicaragua in 1988 to that in 1991?
Offer a very short reply. 0.49. What is the ratio of the Aid flow (current US$) in Sierra Leone in 1988 to that in 1991?
Provide a succinct answer. 0.75. What is the ratio of the Aid flow (current US$) in Tunisia in 1988 to that in 1991?
Make the answer very short. 0.2. What is the ratio of the Aid flow (current US$) in Bhutan in 1988 to that in 1995?
Make the answer very short. 9. What is the ratio of the Aid flow (current US$) in Nicaragua in 1988 to that in 1995?
Offer a very short reply. 0.36. What is the ratio of the Aid flow (current US$) of Tunisia in 1988 to that in 1995?
Make the answer very short. 0.47. What is the ratio of the Aid flow (current US$) in Nicaragua in 1988 to that in 2006?
Give a very brief answer. 0.21. What is the ratio of the Aid flow (current US$) in Sierra Leone in 1988 to that in 2006?
Your answer should be very brief. 0.06. What is the ratio of the Aid flow (current US$) of Tunisia in 1988 to that in 2006?
Offer a very short reply. 0.27. What is the ratio of the Aid flow (current US$) in Bhutan in 1989 to that in 1990?
Your answer should be compact. 1. What is the ratio of the Aid flow (current US$) of Nicaragua in 1989 to that in 1990?
Ensure brevity in your answer.  0.53. What is the ratio of the Aid flow (current US$) in Sierra Leone in 1989 to that in 1990?
Offer a very short reply. 0.8. What is the ratio of the Aid flow (current US$) of Tunisia in 1989 to that in 1990?
Make the answer very short. 0.48. What is the ratio of the Aid flow (current US$) in Nicaragua in 1989 to that in 1991?
Keep it short and to the point. 0.36. What is the ratio of the Aid flow (current US$) of Sierra Leone in 1989 to that in 1991?
Provide a succinct answer. 0.33. What is the ratio of the Aid flow (current US$) of Tunisia in 1989 to that in 1991?
Give a very brief answer. 0.27. What is the ratio of the Aid flow (current US$) in Nicaragua in 1989 to that in 1995?
Your answer should be compact. 0.27. What is the ratio of the Aid flow (current US$) in Sierra Leone in 1989 to that in 1995?
Provide a succinct answer. 0.5. What is the ratio of the Aid flow (current US$) in Tunisia in 1989 to that in 1995?
Your answer should be very brief. 0.64. What is the ratio of the Aid flow (current US$) of Nicaragua in 1989 to that in 2006?
Keep it short and to the point. 0.16. What is the ratio of the Aid flow (current US$) of Sierra Leone in 1989 to that in 2006?
Your answer should be compact. 0.03. What is the ratio of the Aid flow (current US$) of Tunisia in 1989 to that in 2006?
Your answer should be very brief. 0.37. What is the ratio of the Aid flow (current US$) in Bhutan in 1990 to that in 1991?
Provide a short and direct response. 0.2. What is the ratio of the Aid flow (current US$) of Nicaragua in 1990 to that in 1991?
Give a very brief answer. 0.69. What is the ratio of the Aid flow (current US$) of Sierra Leone in 1990 to that in 1991?
Provide a succinct answer. 0.42. What is the ratio of the Aid flow (current US$) of Tunisia in 1990 to that in 1991?
Keep it short and to the point. 0.57. What is the ratio of the Aid flow (current US$) in Bhutan in 1990 to that in 1995?
Offer a very short reply. 1. What is the ratio of the Aid flow (current US$) in Nicaragua in 1990 to that in 1995?
Your answer should be compact. 0.5. What is the ratio of the Aid flow (current US$) in Sierra Leone in 1990 to that in 1995?
Keep it short and to the point. 0.62. What is the ratio of the Aid flow (current US$) of Tunisia in 1990 to that in 1995?
Provide a succinct answer. 1.34. What is the ratio of the Aid flow (current US$) of Bhutan in 1990 to that in 2006?
Give a very brief answer. 1. What is the ratio of the Aid flow (current US$) of Nicaragua in 1990 to that in 2006?
Your response must be concise. 0.3. What is the ratio of the Aid flow (current US$) in Sierra Leone in 1990 to that in 2006?
Ensure brevity in your answer.  0.03. What is the ratio of the Aid flow (current US$) in Tunisia in 1990 to that in 2006?
Your answer should be compact. 0.77. What is the ratio of the Aid flow (current US$) in Nicaragua in 1991 to that in 1995?
Offer a very short reply. 0.73. What is the ratio of the Aid flow (current US$) of Tunisia in 1991 to that in 1995?
Provide a short and direct response. 2.35. What is the ratio of the Aid flow (current US$) in Nicaragua in 1991 to that in 2006?
Give a very brief answer. 0.43. What is the ratio of the Aid flow (current US$) of Sierra Leone in 1991 to that in 2006?
Provide a short and direct response. 0.08. What is the ratio of the Aid flow (current US$) in Tunisia in 1991 to that in 2006?
Keep it short and to the point. 1.36. What is the ratio of the Aid flow (current US$) in Nicaragua in 1995 to that in 2006?
Your response must be concise. 0.59. What is the ratio of the Aid flow (current US$) of Sierra Leone in 1995 to that in 2006?
Give a very brief answer. 0.05. What is the ratio of the Aid flow (current US$) of Tunisia in 1995 to that in 2006?
Make the answer very short. 0.58. What is the difference between the highest and the second highest Aid flow (current US$) in Bhutan?
Offer a terse response. 10000. What is the difference between the highest and the second highest Aid flow (current US$) of Nicaragua?
Your answer should be compact. 2.28e+06. What is the difference between the highest and the second highest Aid flow (current US$) in Sierra Leone?
Your response must be concise. 1.43e+06. What is the difference between the highest and the second highest Aid flow (current US$) in Tunisia?
Your response must be concise. 3.42e+06. What is the difference between the highest and the lowest Aid flow (current US$) in Nicaragua?
Offer a very short reply. 4.98e+06. What is the difference between the highest and the lowest Aid flow (current US$) in Sierra Leone?
Provide a short and direct response. 1.51e+06. What is the difference between the highest and the lowest Aid flow (current US$) in Tunisia?
Offer a terse response. 1.04e+07. 